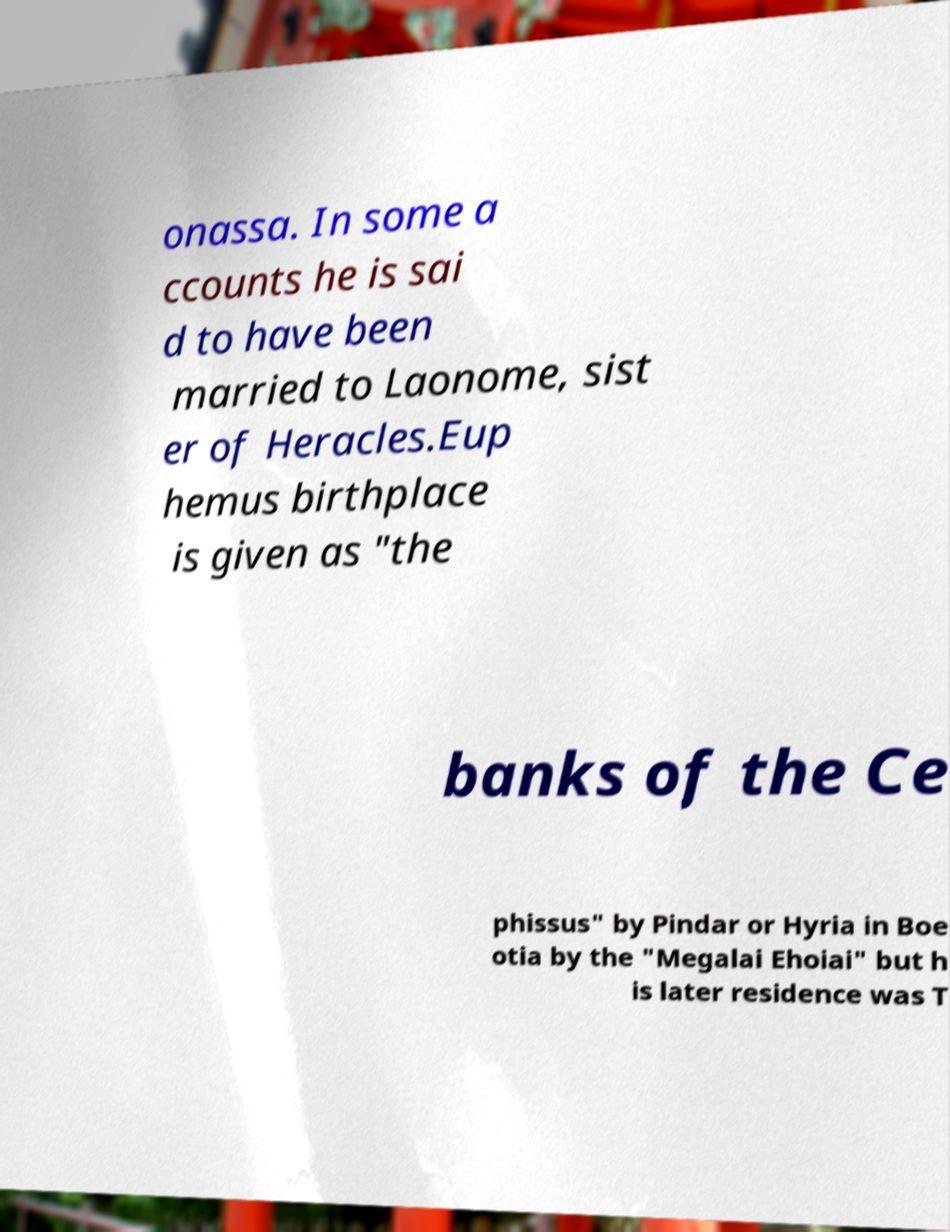Can you read and provide the text displayed in the image?This photo seems to have some interesting text. Can you extract and type it out for me? onassa. In some a ccounts he is sai d to have been married to Laonome, sist er of Heracles.Eup hemus birthplace is given as "the banks of the Ce phissus" by Pindar or Hyria in Boe otia by the "Megalai Ehoiai" but h is later residence was T 